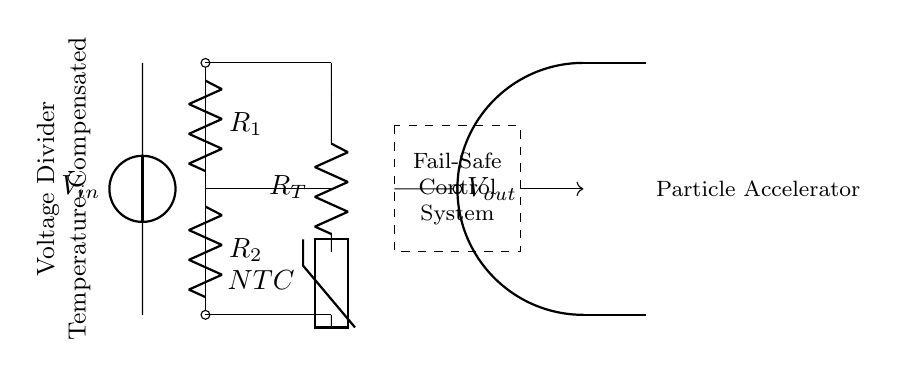What is the input voltage symbolized in the circuit? The input voltage is represented by the symbol V with a subscript in, indicating it's the voltage supplied to the circuit.
Answer: Vin What are the resistors used in the voltage divider? The circuit has two resistors denoted as R1 and R2, which are used in series to create the voltage division.
Answer: R1, R2 What is the role of the thermistor in this circuit? The thermistor, labeled as NTC, is used for temperature compensation, meaning it adjusts resistance based on temperature changes to keep output stable.
Answer: Temperature Compensation How does the fail-safe mechanism protect the system? The fail-safe mechanism, indicated by the dashed rectangle, provides a layer of protection in case of an error, ensuring safe operation of the control system.
Answer: Protection Layer What is the output voltage represented in the circuit? The output voltage is indicated by V with a subscript out, which is the voltage derived from the voltage divider made by R1 and R2.
Answer: Vout What is the configuration of R1 and R2 in the voltage divider? The resistors R1 and R2 are arranged in series to divide the input voltage into smaller output voltage.
Answer: Series Configuration How does temperature affect the behavior of the NTC thermistor in this circuit? An NTC thermistor decreases its resistance with increasing temperature, which influences the voltage across the divider to maintain stability despite temperature variations.
Answer: Resistance Decreases with Temperature 